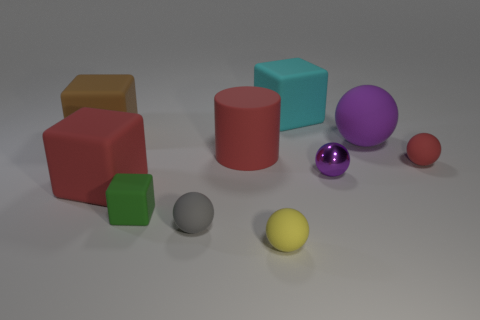Is there anything else that has the same material as the tiny purple thing?
Your answer should be very brief. No. The matte ball that is the same color as the cylinder is what size?
Your answer should be compact. Small. Do the large matte sphere and the tiny metallic sphere have the same color?
Make the answer very short. Yes. Are there more matte objects that are right of the big brown cube than gray spheres that are in front of the tiny gray matte sphere?
Give a very brief answer. Yes. Do the brown block and the red object on the left side of the tiny cube have the same material?
Give a very brief answer. Yes. What color is the tiny shiny sphere?
Offer a very short reply. Purple. There is a small rubber thing that is to the right of the yellow matte ball; what shape is it?
Your answer should be very brief. Sphere. What number of brown objects are small cubes or shiny objects?
Your response must be concise. 0. There is a big cylinder that is made of the same material as the large cyan object; what is its color?
Give a very brief answer. Red. Do the big cylinder and the tiny matte ball that is right of the yellow ball have the same color?
Your answer should be compact. Yes. 